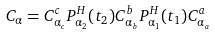Convert formula to latex. <formula><loc_0><loc_0><loc_500><loc_500>C _ { \alpha } = C ^ { c } _ { \alpha _ { c } } P ^ { H } _ { \alpha _ { 2 } } ( t _ { 2 } ) C ^ { b } _ { \alpha _ { b } } P ^ { H } _ { \alpha _ { 1 } } ( t _ { 1 } ) C ^ { a } _ { \alpha _ { a } }</formula> 